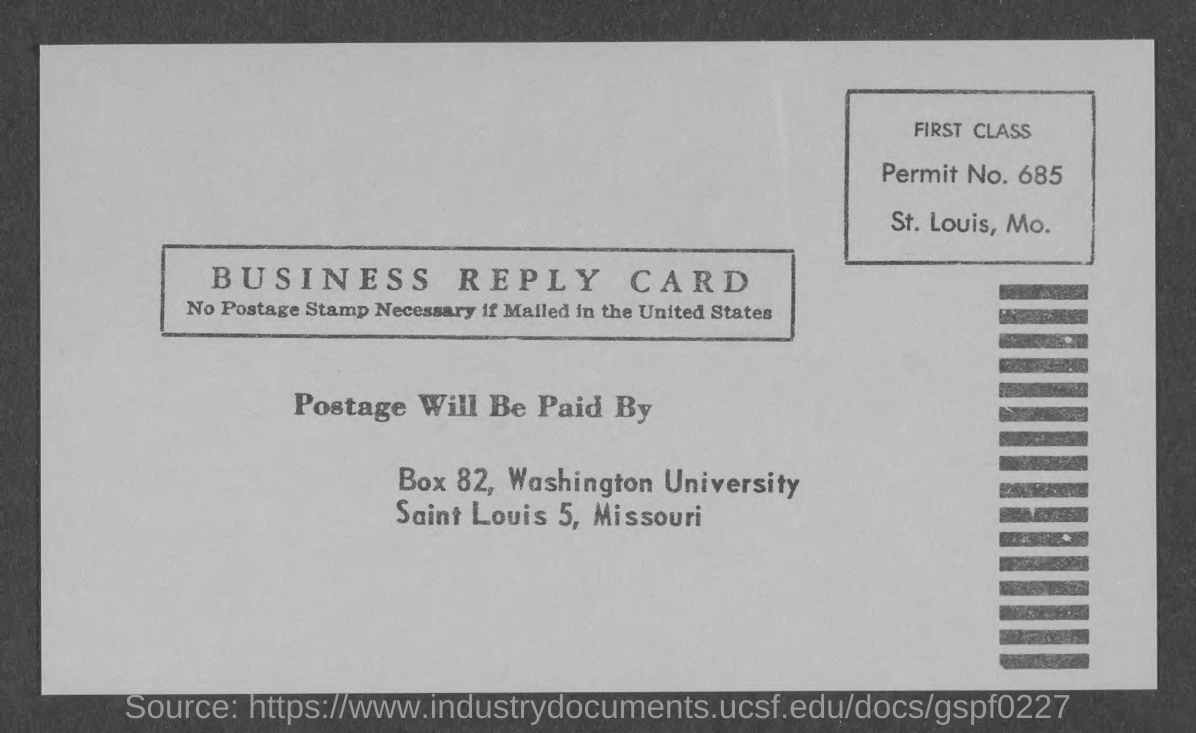What is the permit no.?
Your answer should be compact. 685. 